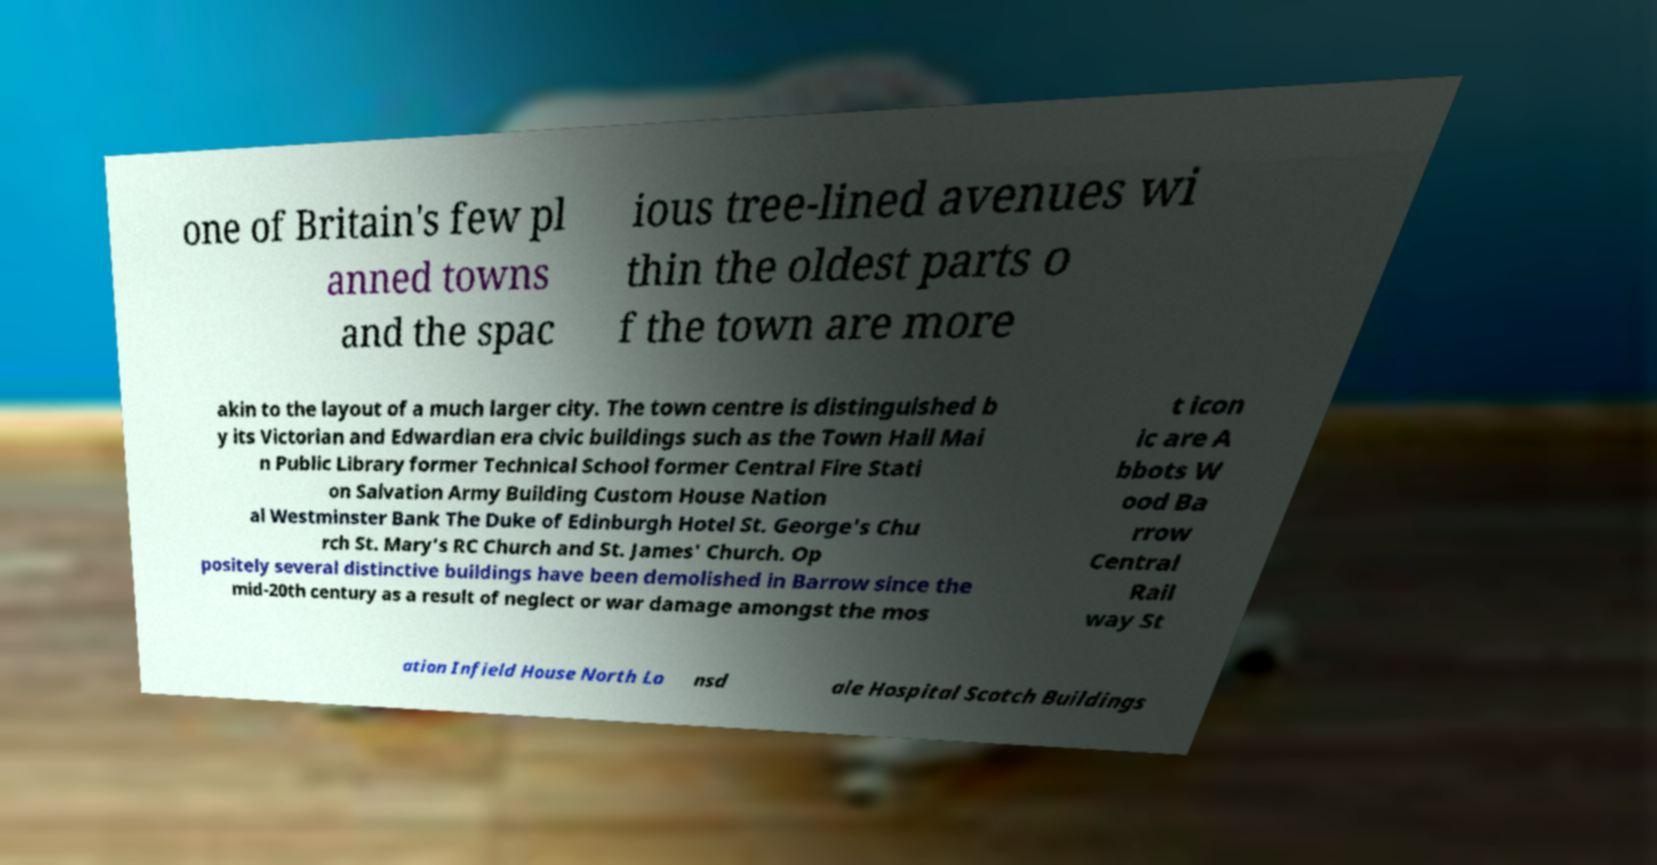I need the written content from this picture converted into text. Can you do that? one of Britain's few pl anned towns and the spac ious tree-lined avenues wi thin the oldest parts o f the town are more akin to the layout of a much larger city. The town centre is distinguished b y its Victorian and Edwardian era civic buildings such as the Town Hall Mai n Public Library former Technical School former Central Fire Stati on Salvation Army Building Custom House Nation al Westminster Bank The Duke of Edinburgh Hotel St. George's Chu rch St. Mary's RC Church and St. James' Church. Op positely several distinctive buildings have been demolished in Barrow since the mid-20th century as a result of neglect or war damage amongst the mos t icon ic are A bbots W ood Ba rrow Central Rail way St ation Infield House North Lo nsd ale Hospital Scotch Buildings 